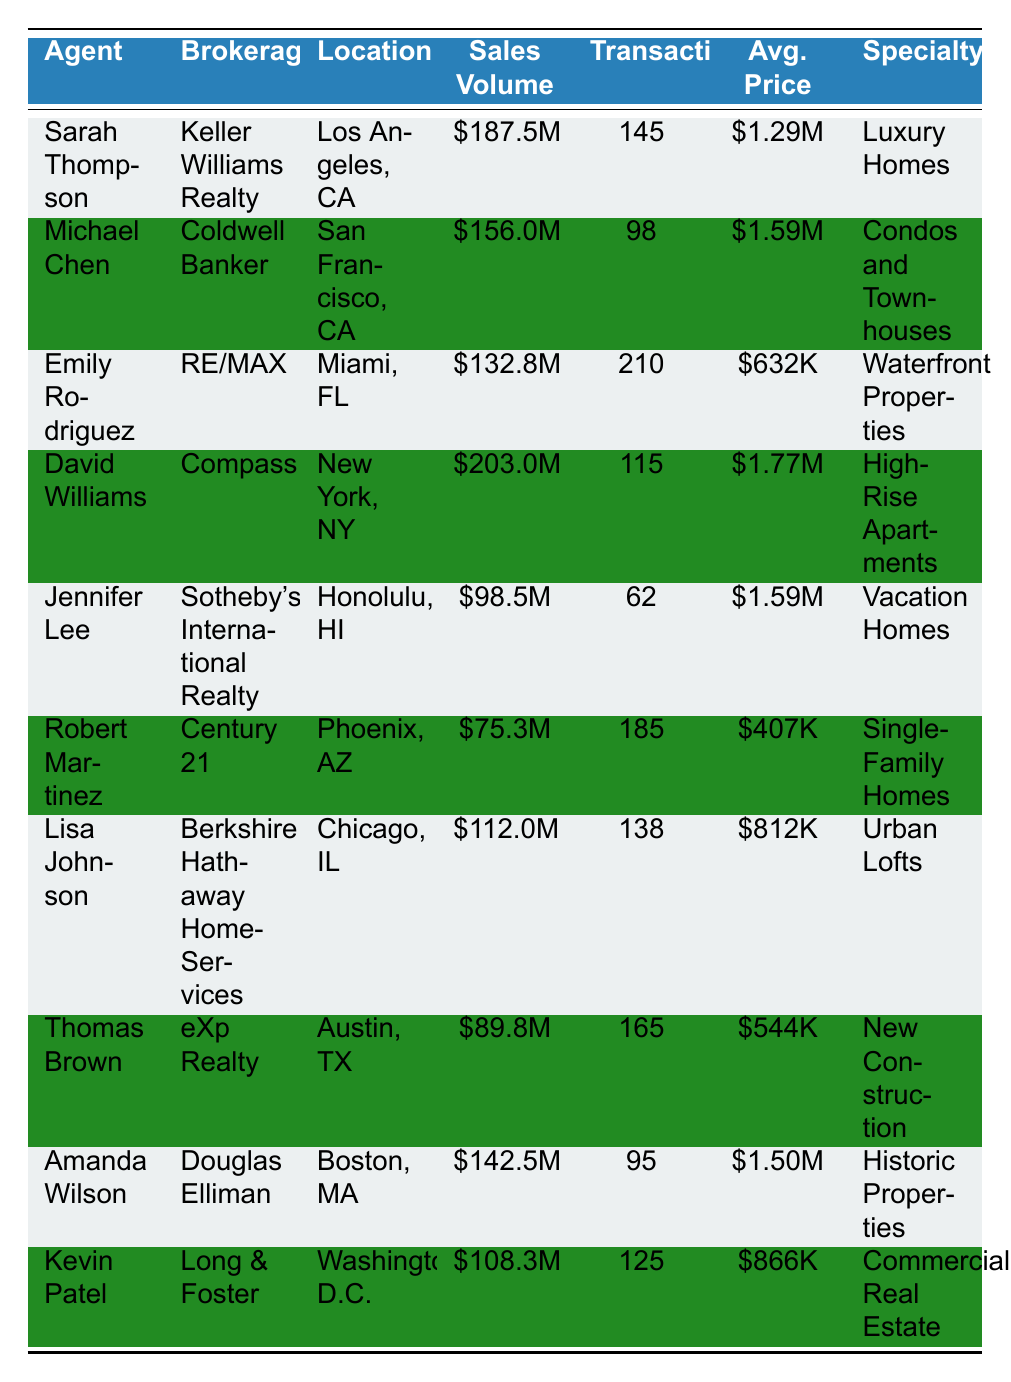What is the highest sales volume among the agents? Looking at the sales volume column, the highest value is for David Williams with \$203.0 million.
Answer: \$203.0 million Who has the highest average price of sales? The average price column shows that David Williams has the highest average price at \$1.77 million.
Answer: \$1.77 million How many transactions did Emily Rodriguez complete? Emily Rodriguez completed 210 transactions as stated in the transactions column.
Answer: 210 Is Amanda Wilson's sales volume higher than that of Sarah Thompson? Amanda Wilson's sales volume is \$142.5 million, while Sarah Thompson's is \$187.5 million; hence, Amanda's volume is lower.
Answer: No What is the total sales volume for Robert Martinez and Thomas Brown? Adding the sales volumes of Robert Martinez (\$75.3 million) and Thomas Brown (\$89.8 million) gives a total of \$165.1 million.
Answer: \$165.1 million Which agent specializes in luxury homes? From the specialty column, Sarah Thompson specializes in luxury homes.
Answer: Sarah Thompson Calculate the average number of transactions for all agents in the table. Summing all transactions (145 + 98 + 210 + 115 + 62 + 185 + 138 + 165 + 95 + 125 = 1,430) and dividing by 10 agents gives an average of 143 transactions.
Answer: 143 Is there an agent from Chicago in the table? Yes, Lisa Johnson is listed as an agent from Chicago, IL.
Answer: Yes Which agent has the least number of transactions? Jennifer Lee has the least number of transactions with 62 as indicated in the transactions column.
Answer: 62 What is the difference in sales volume between the agent with the highest and the agent with the lowest? The highest sales volume is \$203.0 million (David Williams) and the lowest is \$75.3 million (Robert Martinez); the difference is \$127.7 million.
Answer: \$127.7 million Which location has an agent with a sales volume above \$150 million? The locations of agents with sales volumes above \$150 million are Los Angeles (Sarah Thompson) and New York (David Williams).
Answer: Los Angeles and New York 